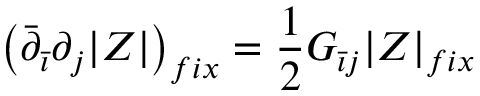<formula> <loc_0><loc_0><loc_500><loc_500>\left ( \bar { \partial } _ { \bar { \imath } } \partial _ { j } | Z | \right ) _ { f i x } = \frac { 1 } { 2 } G _ { \bar { \imath } j } | Z | _ { f i x }</formula> 